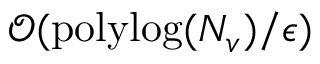Convert formula to latex. <formula><loc_0><loc_0><loc_500><loc_500>\mathcal { O } ( p o l y \log ( N _ { v } ) / \epsilon )</formula> 